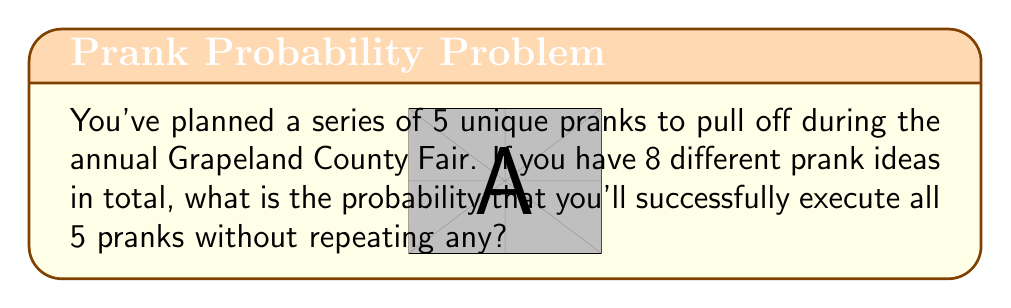Teach me how to tackle this problem. Let's approach this step-by-step:

1) This is a permutation problem because the order of pranks matters (you're executing them in a series) and we're not repeating any pranks.

2) We need to calculate the number of ways to choose and arrange 5 pranks out of 8 total prank ideas. This is denoted as $P(8,5)$.

3) The formula for permutation is:

   $$P(n,r) = \frac{n!}{(n-r)!}$$

   Where $n$ is the total number of items to choose from, and $r$ is the number of items being chosen.

4) In this case, $n = 8$ and $r = 5$. Let's plug these into our formula:

   $$P(8,5) = \frac{8!}{(8-5)!} = \frac{8!}{3!}$$

5) Let's calculate this:
   
   $$\frac{8!}{3!} = \frac{8 \times 7 \times 6 \times 5!}{3 \times 2 \times 1} = 6720$$

6) This means there are 6720 ways to choose and arrange 5 pranks out of 8.

7) The probability of successfully executing this specific series of 5 pranks is 1 out of all possible arrangements:

   $$Probability = \frac{1}{6720}$$
Answer: $\frac{1}{6720}$ or approximately $0.000149$ 